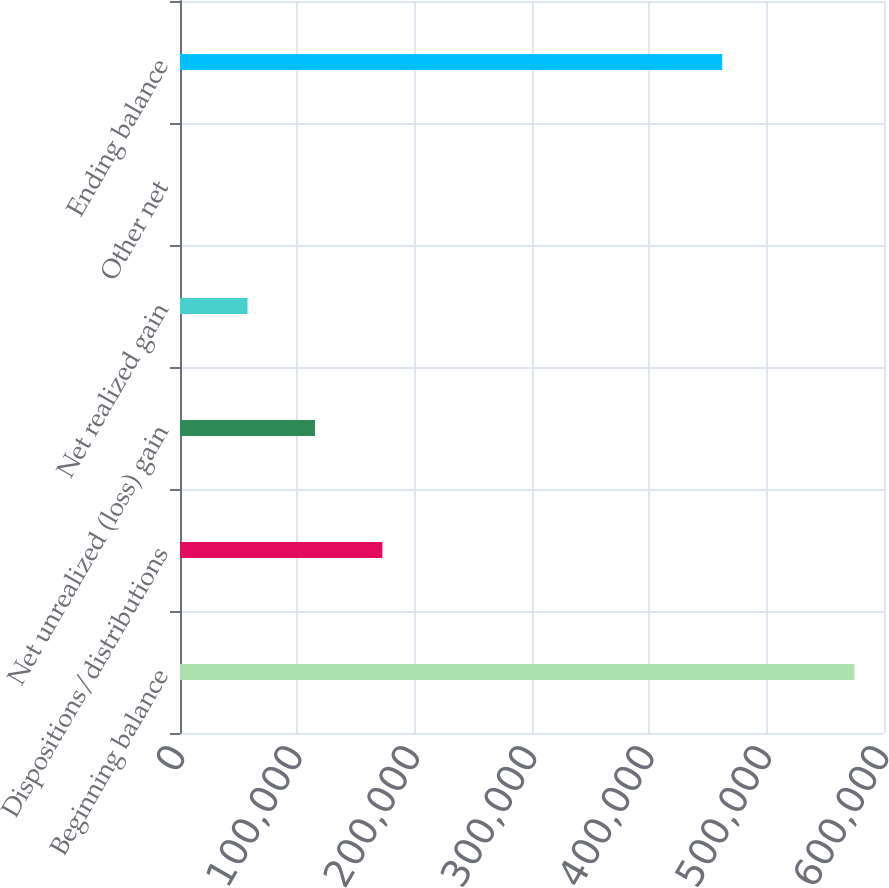Convert chart to OTSL. <chart><loc_0><loc_0><loc_500><loc_500><bar_chart><fcel>Beginning balance<fcel>Dispositions/distributions<fcel>Net unrealized (loss) gain<fcel>Net realized gain<fcel>Other net<fcel>Ending balance<nl><fcel>574761<fcel>172488<fcel>115021<fcel>57553.5<fcel>86<fcel>462132<nl></chart> 